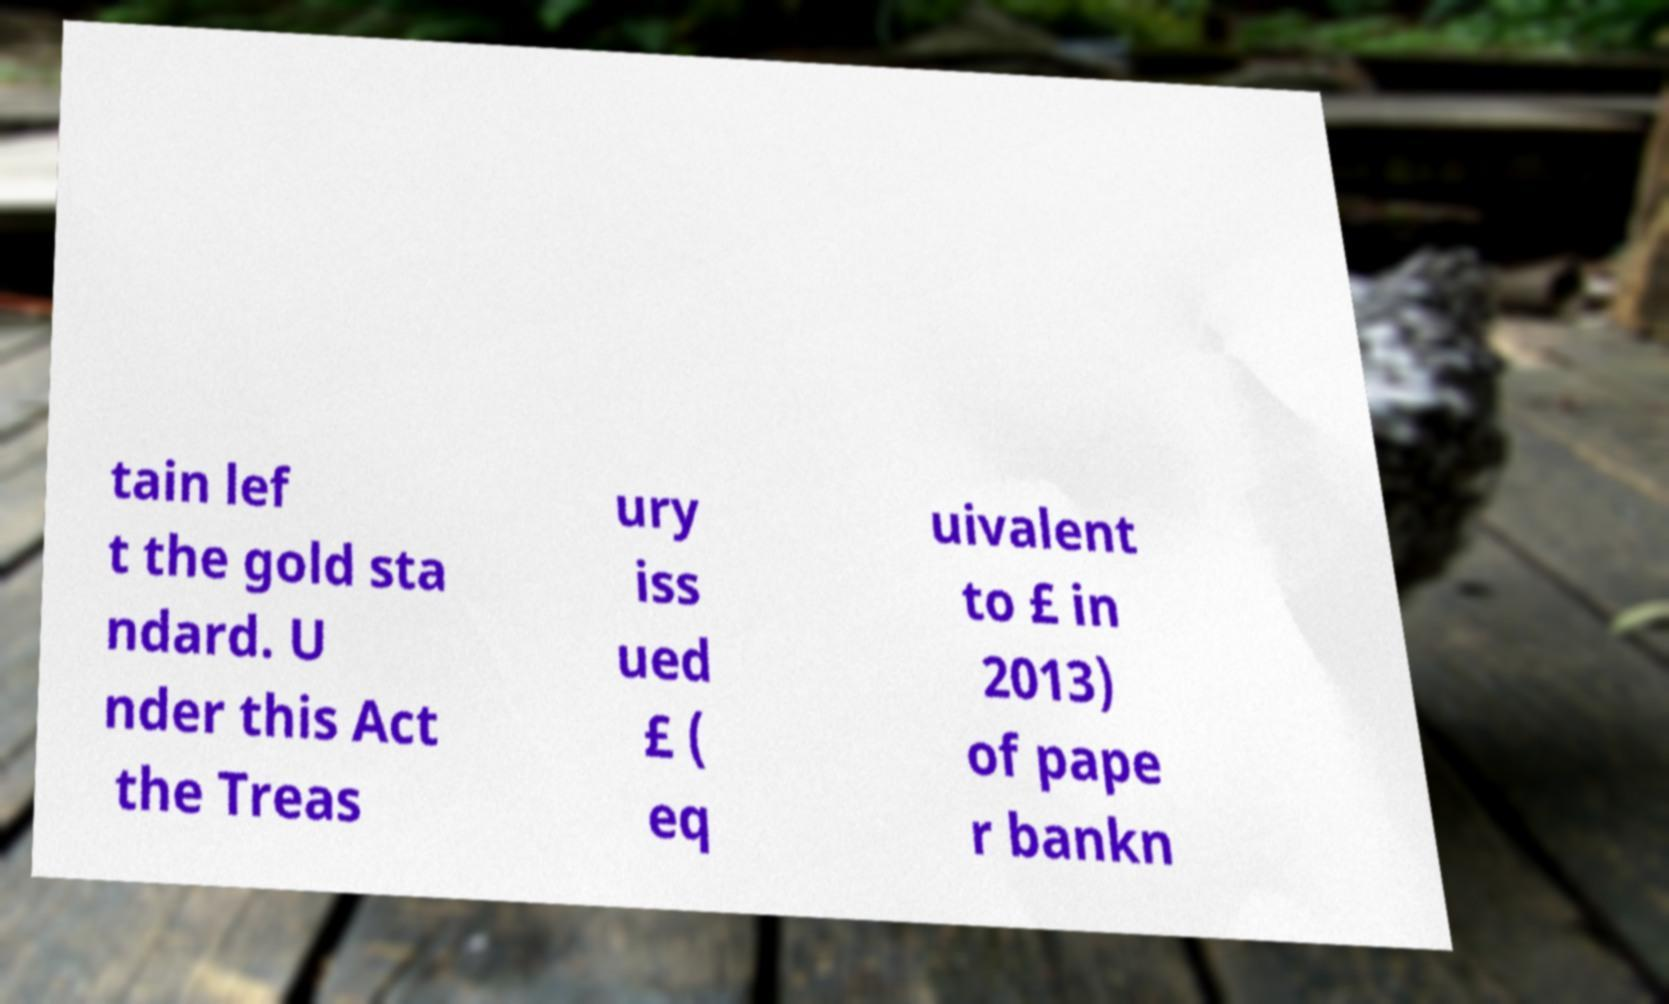Could you assist in decoding the text presented in this image and type it out clearly? tain lef t the gold sta ndard. U nder this Act the Treas ury iss ued £ ( eq uivalent to £ in 2013) of pape r bankn 